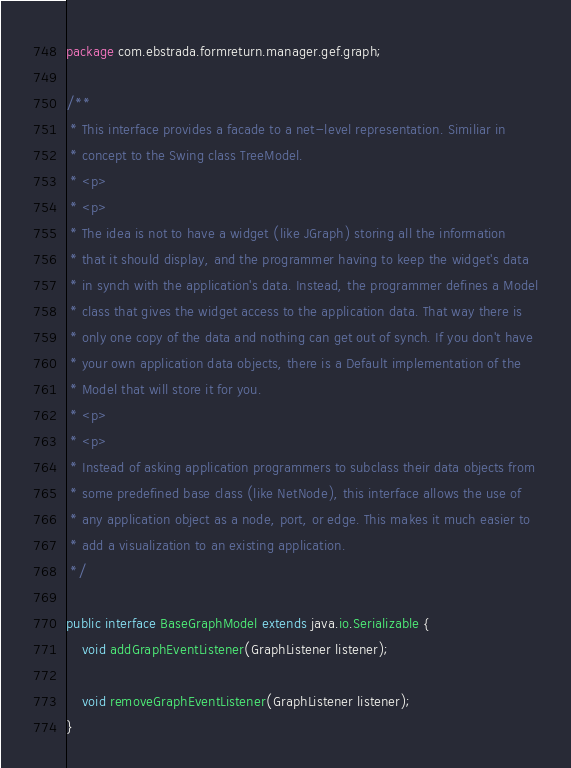Convert code to text. <code><loc_0><loc_0><loc_500><loc_500><_Java_>package com.ebstrada.formreturn.manager.gef.graph;

/**
 * This interface provides a facade to a net-level representation. Similiar in
 * concept to the Swing class TreeModel.
 * <p>
 * <p>
 * The idea is not to have a widget (like JGraph) storing all the information
 * that it should display, and the programmer having to keep the widget's data
 * in synch with the application's data. Instead, the programmer defines a Model
 * class that gives the widget access to the application data. That way there is
 * only one copy of the data and nothing can get out of synch. If you don't have
 * your own application data objects, there is a Default implementation of the
 * Model that will store it for you.
 * <p>
 * <p>
 * Instead of asking application programmers to subclass their data objects from
 * some predefined base class (like NetNode), this interface allows the use of
 * any application object as a node, port, or edge. This makes it much easier to
 * add a visualization to an existing application.
 */

public interface BaseGraphModel extends java.io.Serializable {
    void addGraphEventListener(GraphListener listener);

    void removeGraphEventListener(GraphListener listener);
}
</code> 